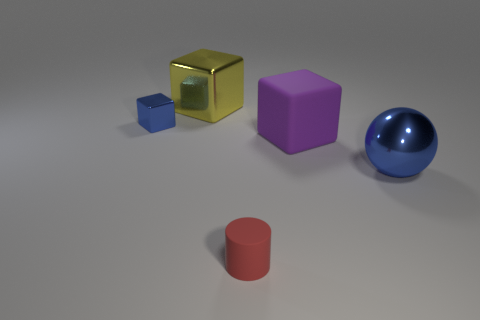Are any shiny spheres visible?
Keep it short and to the point. Yes. Are there any large purple things left of the thing in front of the blue sphere?
Provide a short and direct response. No. What material is the blue object that is the same shape as the yellow metal object?
Offer a terse response. Metal. Is the number of cyan things greater than the number of small cylinders?
Your answer should be very brief. No. There is a big matte thing; is its color the same as the large metallic thing behind the matte block?
Offer a terse response. No. There is a thing that is both right of the red rubber cylinder and on the left side of the big blue thing; what is its color?
Ensure brevity in your answer.  Purple. How many other things are there of the same material as the tiny red cylinder?
Your answer should be compact. 1. Are there fewer tiny purple rubber things than yellow metal things?
Your response must be concise. Yes. Are the big blue thing and the big thing to the left of the matte cube made of the same material?
Ensure brevity in your answer.  Yes. There is a blue thing right of the yellow metal object; what shape is it?
Make the answer very short. Sphere. 